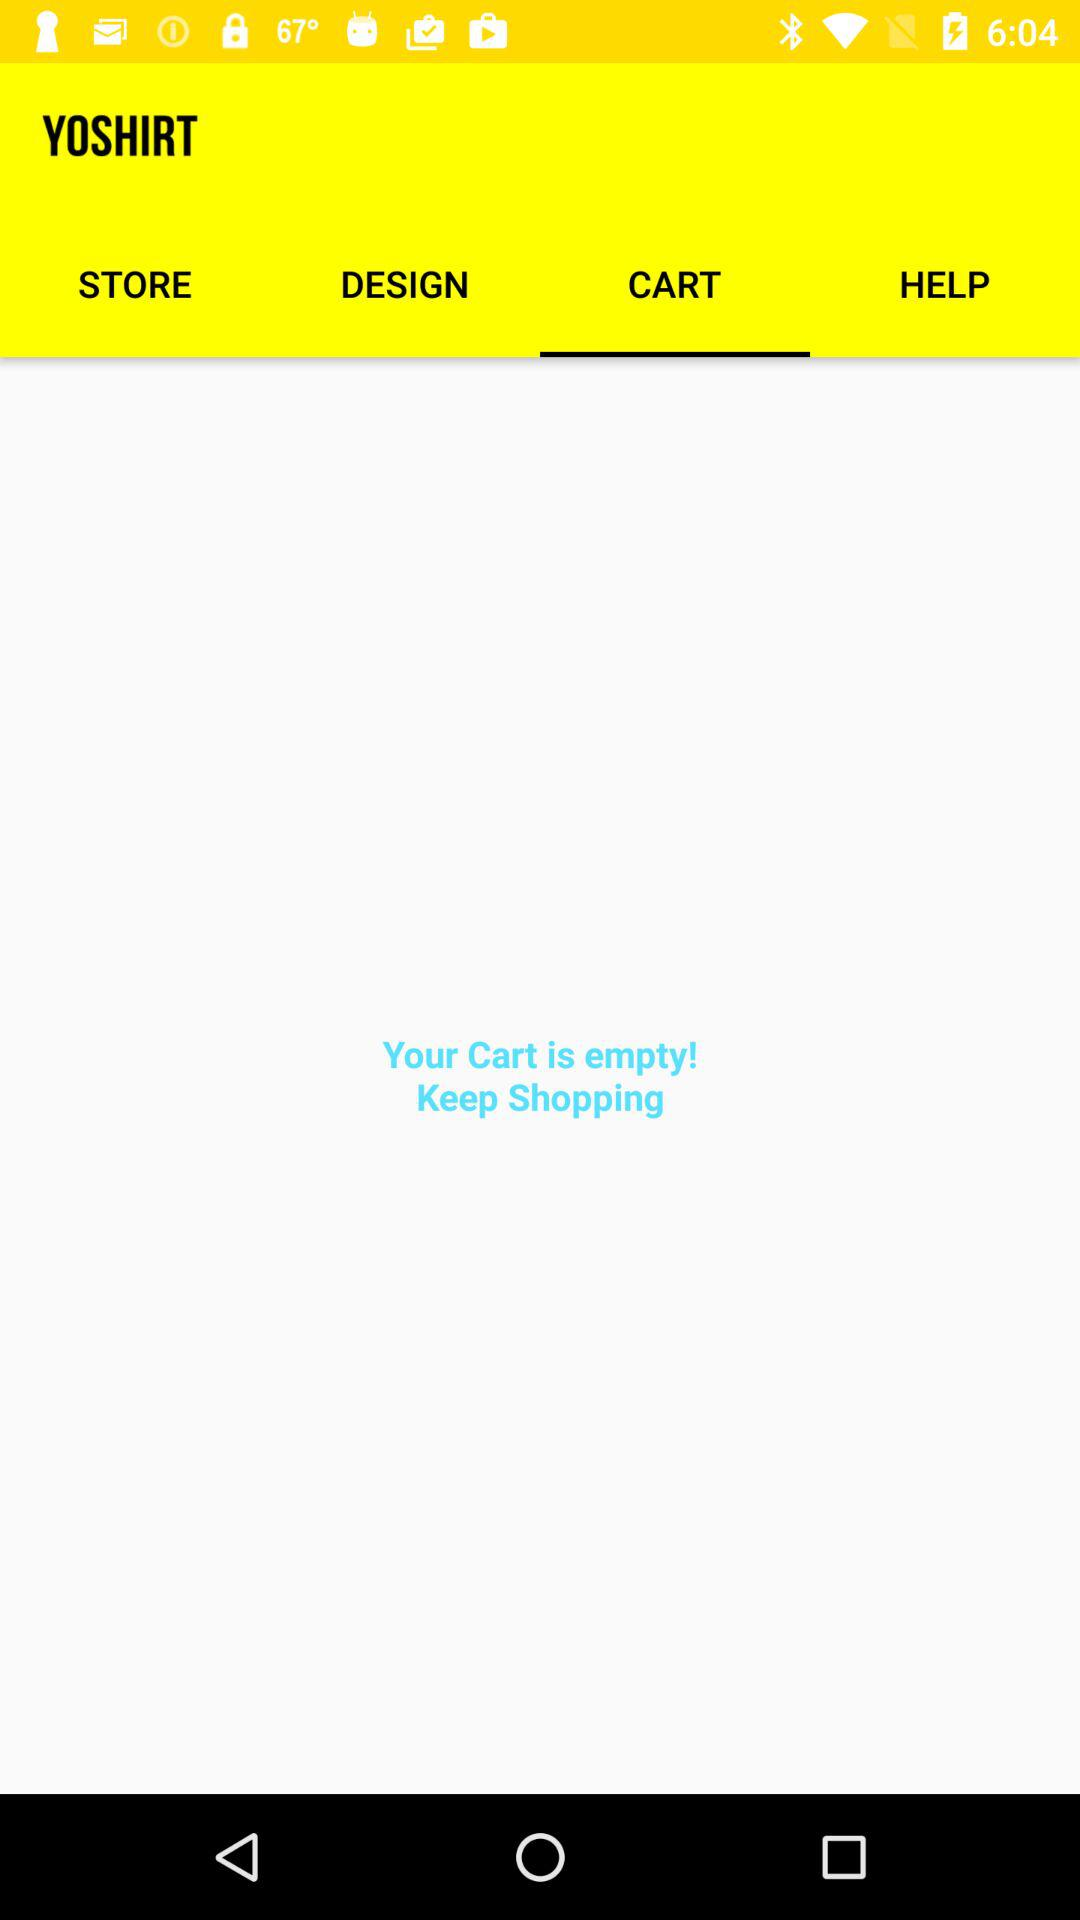How many items are in the cart?
Answer the question using a single word or phrase. 0 